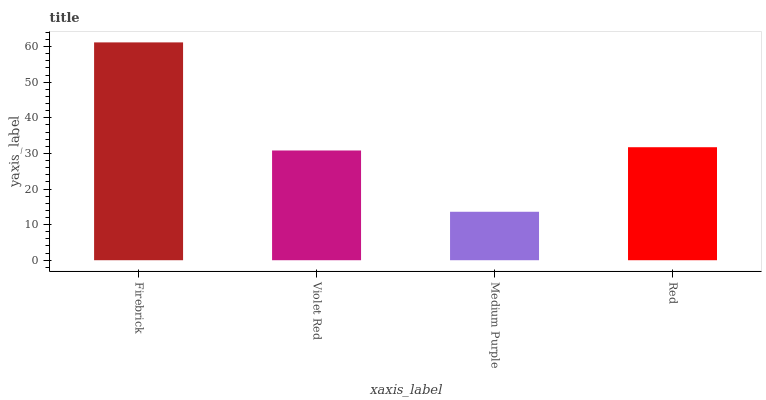Is Violet Red the minimum?
Answer yes or no. No. Is Violet Red the maximum?
Answer yes or no. No. Is Firebrick greater than Violet Red?
Answer yes or no. Yes. Is Violet Red less than Firebrick?
Answer yes or no. Yes. Is Violet Red greater than Firebrick?
Answer yes or no. No. Is Firebrick less than Violet Red?
Answer yes or no. No. Is Red the high median?
Answer yes or no. Yes. Is Violet Red the low median?
Answer yes or no. Yes. Is Medium Purple the high median?
Answer yes or no. No. Is Firebrick the low median?
Answer yes or no. No. 